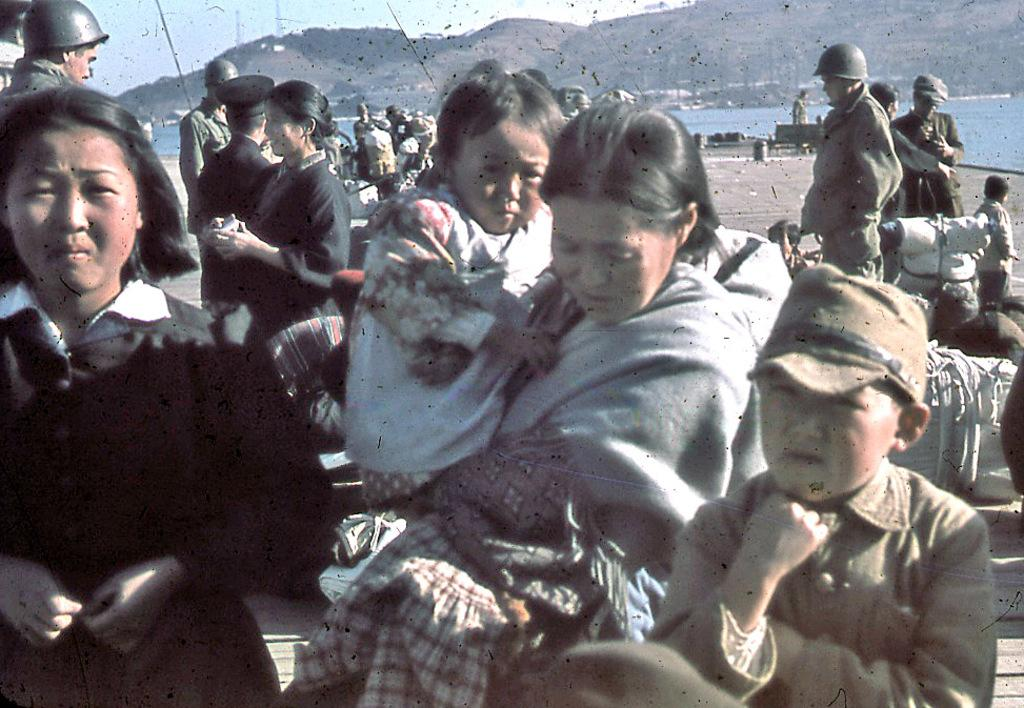How many people are in the image? There is a group of people in the image, but the exact number cannot be determined from the provided facts. What is the primary element visible in the image? Water is visible in the image. What can be seen in the background of the image? There is a mountain and the sky visible in the background of the image. What type of light can be seen reflecting off the water in the image? There is no mention of any specific type of light reflecting off the water in the image. 